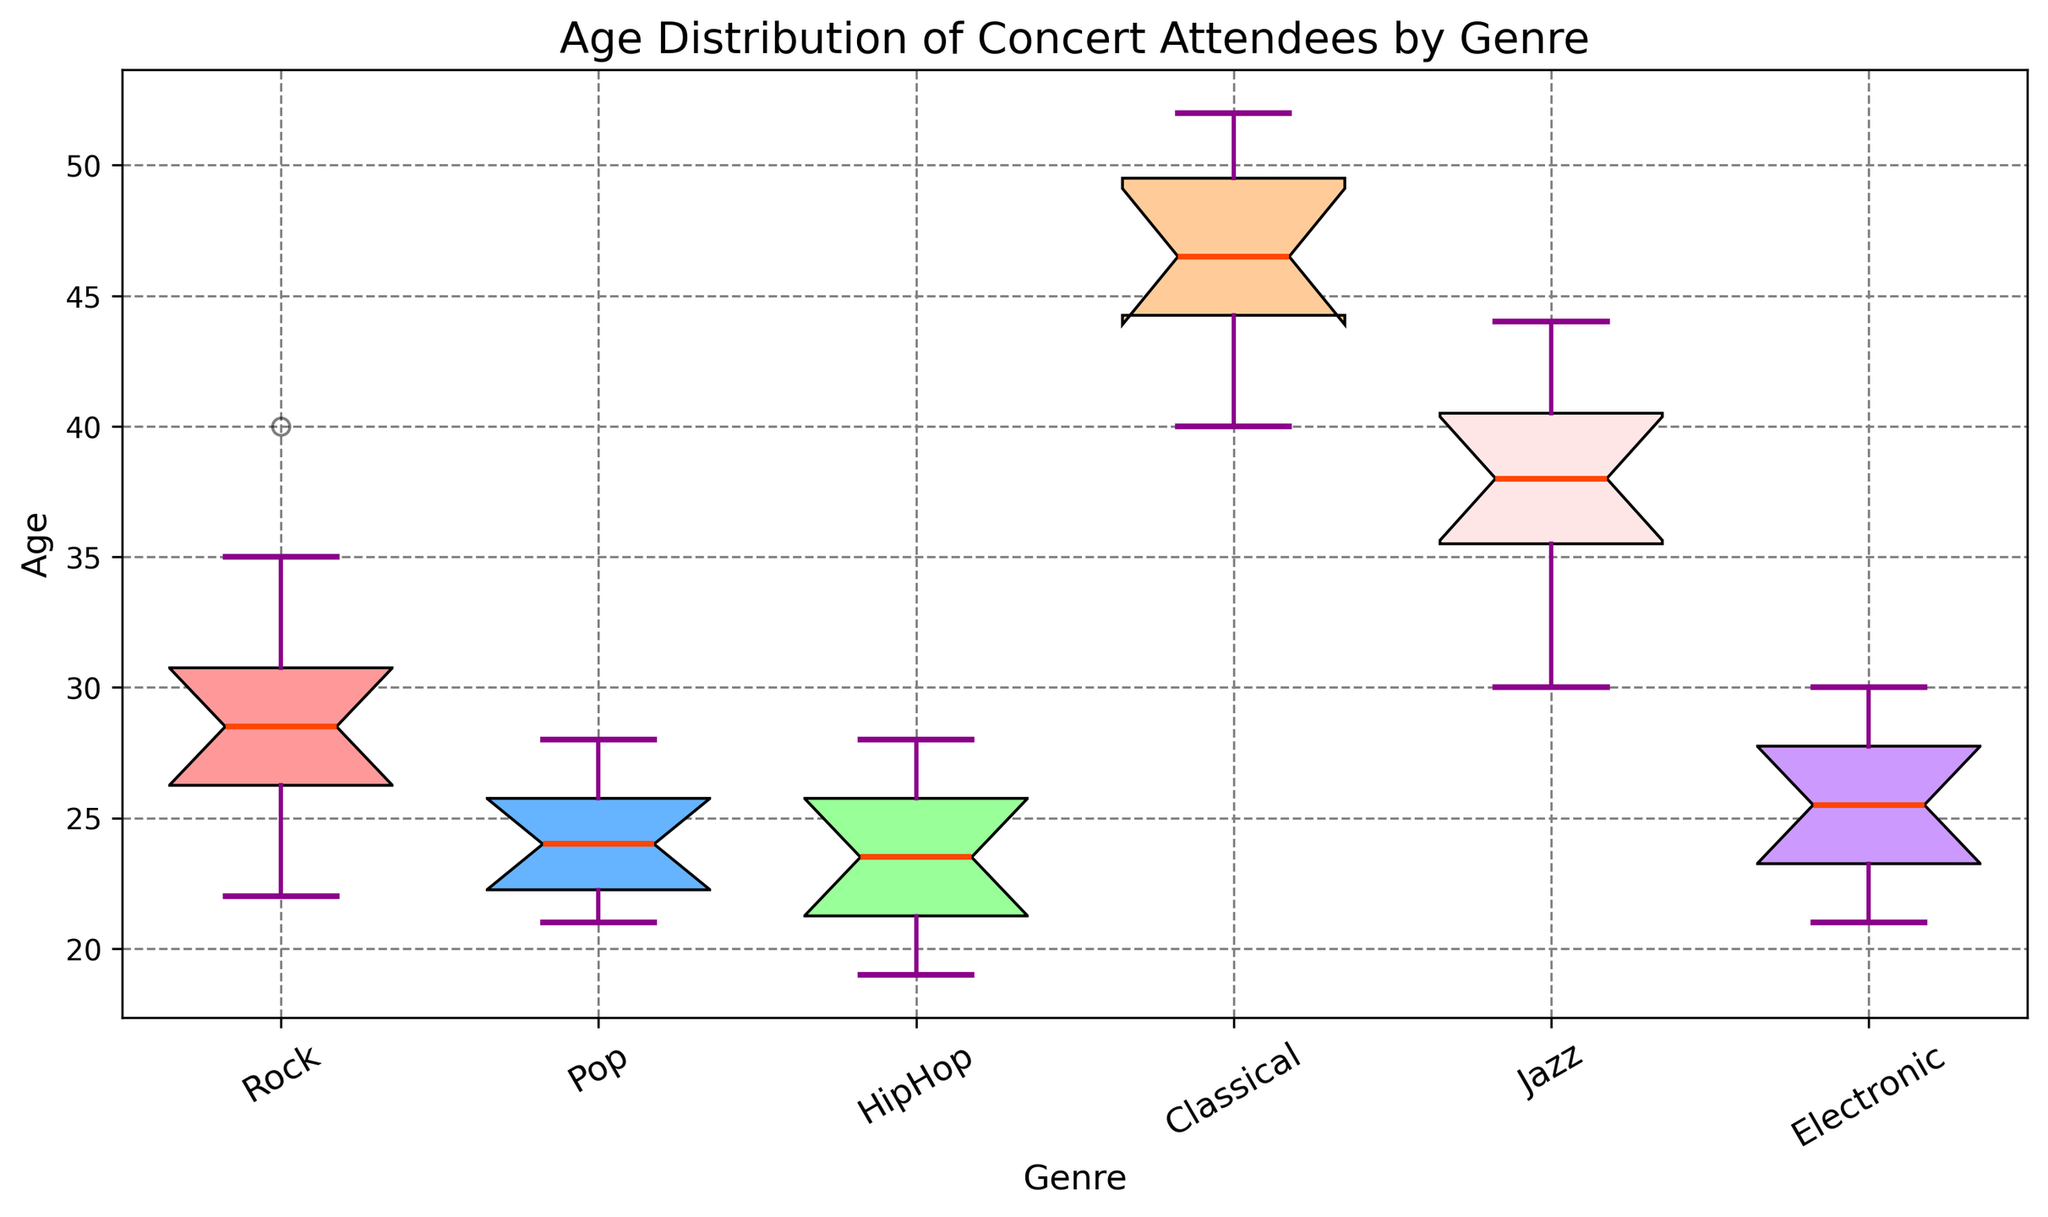Which genre has the widest age range? The age range is the difference between the maximum and minimum ages. Looking at the box plots, Classical has the widest spread from the minimum whisker to the maximum whisker.
Answer: Classical Which genre has the highest median age? The median is the middle line inside the box of each box plot. The highest median line is observed in the box plot for Classical.
Answer: Classical What is the approximate age range for HipHop attendees? The age range can be seen from the bottom to the top whisker of the box plot for HipHop. It spans from approximately 19 to 28 years old.
Answer: 19 to 28 years old Which genres have their median ages closest to 25? The median age is the line in the middle of the box. Both Rock and Electronic have median lines close to the age of 25.
Answer: Rock, Electronic Is the interquartile range (IQR) of Pop attendees smaller or larger than that of Jazz attendees? The IQR is the distance between the bottom and top edges of the box. The IQR for Pop appears to be smaller than the IQR for Jazz.
Answer: Smaller Which genre’s attendees are generally older, Classical or Rock? By looking at the medians and the overall position of the box plots, Classical attendees are generally older than Rock attendees.
Answer: Classical What is the interquartile range (IQR) for Jazz attendees? The IQR is the range between the lower quartile (Q1) and the upper quartile (Q3). For Jazz, estimate Q1 and Q3 by looking at the edges of the box. Q1 is around 36, Q3 is about 41. Therefore, IQR = 41 - 36 = 5.
Answer: 5 Does Electronic have any potential outliers, and if so, what are their approximate ages? Outliers are shown as points outside the whiskers. For Electronic, there is one outlier, which is roughly around 21 years old.
Answer: Yes, around 21 years old What is the middle 50% age range of Rock attendees? The middle 50% is the interquartile range (IQR). For Rock, the bottom and top edges of the box are approximately 26 and 35. Thus, the middle 50% age range is from 26 to 35.
Answer: 26 to 35 